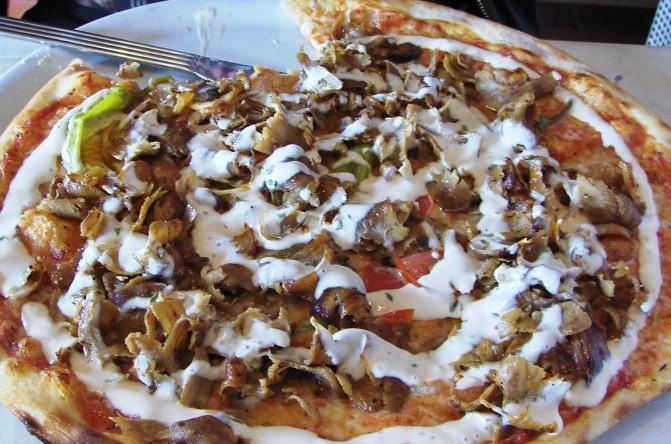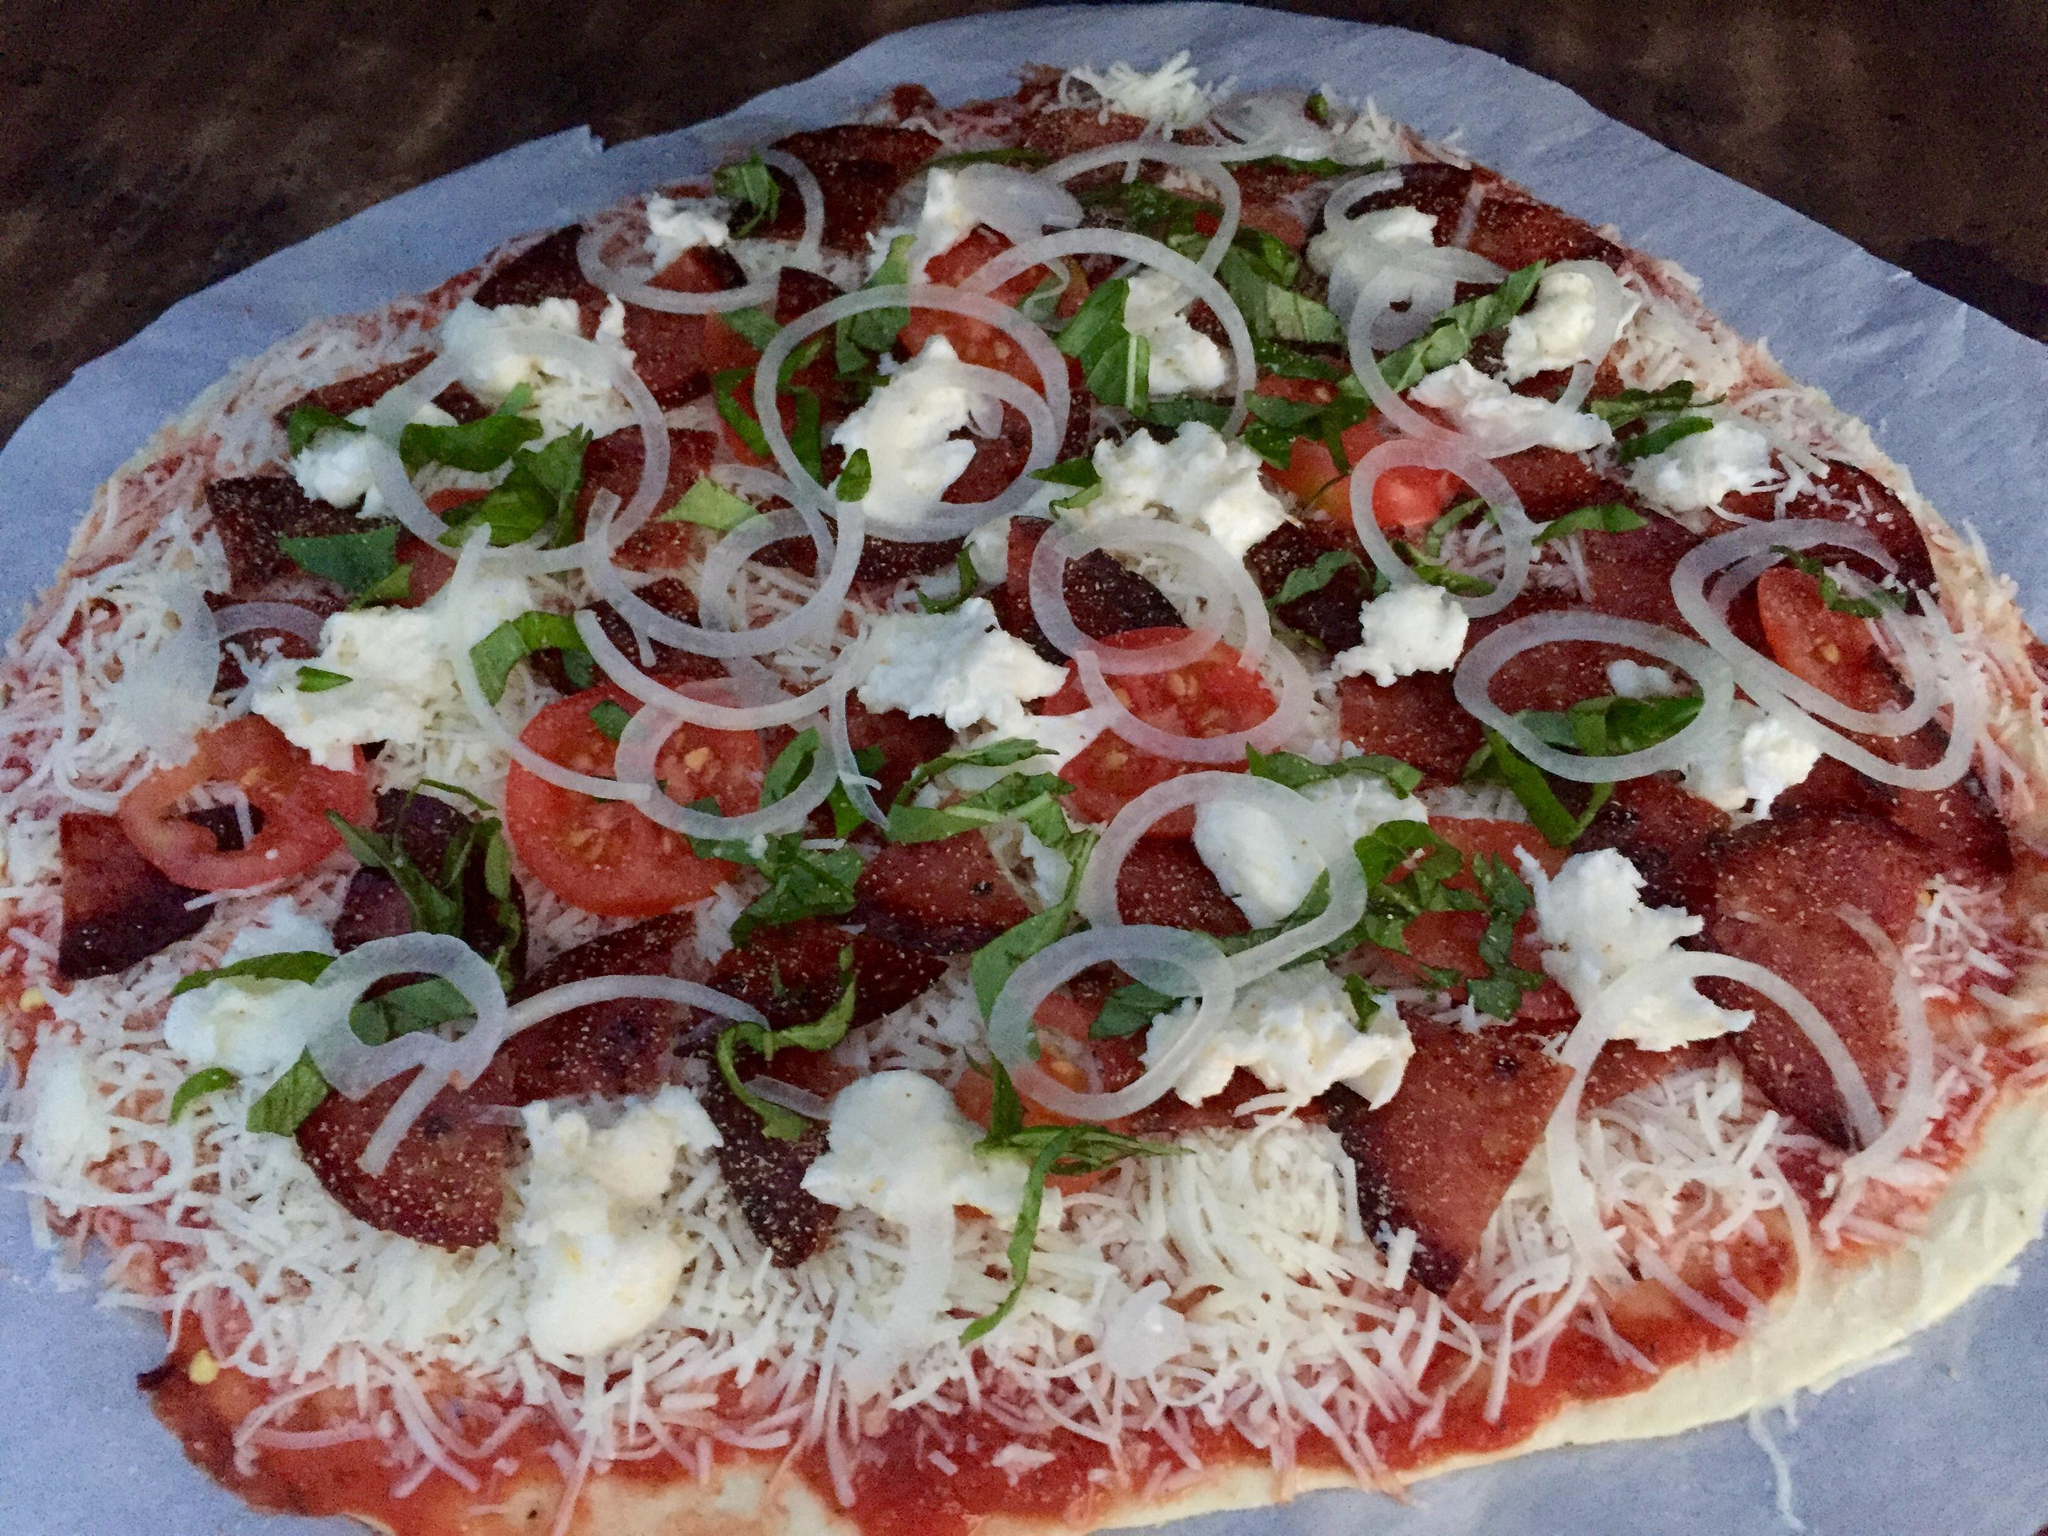The first image is the image on the left, the second image is the image on the right. Assess this claim about the two images: "A pizza has sliced tomatoes.". Correct or not? Answer yes or no. Yes. The first image is the image on the left, the second image is the image on the right. Assess this claim about the two images: "One image shows a baked, brown-crusted pizza with no slices removed, and the other image shows less than an entire pizza.". Correct or not? Answer yes or no. No. 